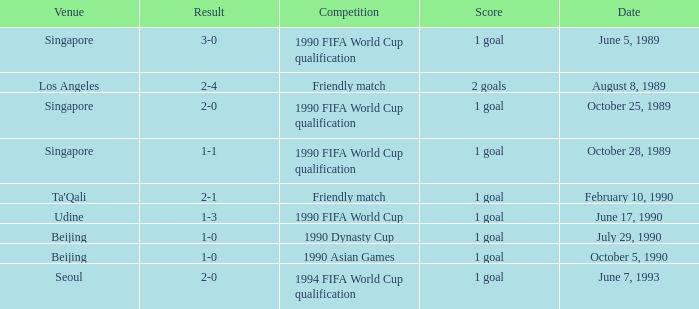What is the venue of the 1990 Asian games? Beijing. 